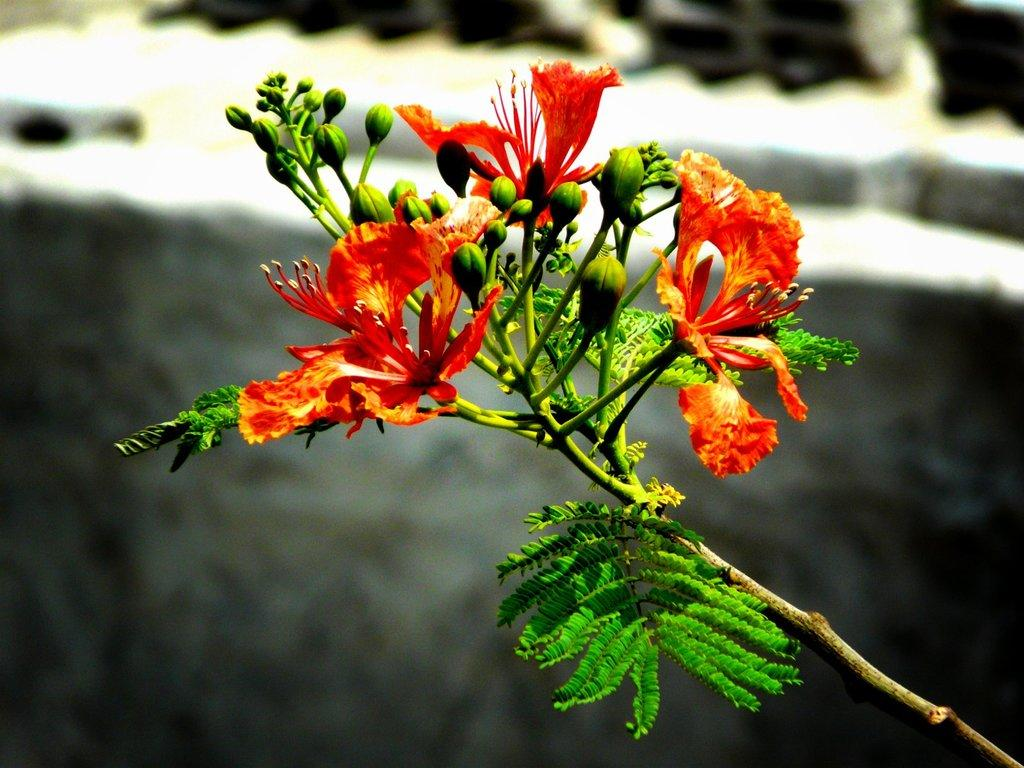What type of plant is in the image? The plant in the image has flowers and green leaves. What can be seen on the plant in the image? The plant has flowers and green leaves. What is present in the background of the image? There is a rock in the background of the image. How is the background of the image depicted? The background is blurred. What type of bait is used to catch the fish in the image? There are no fish or bait present in the image; it features a plant with flowers and green leaves, a rock in the background, and a blurred background. 